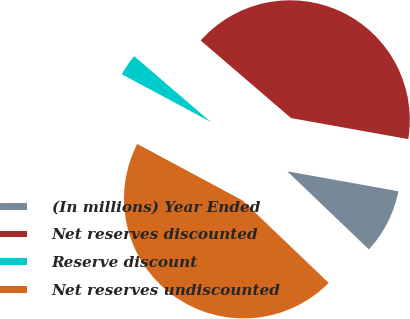Convert chart to OTSL. <chart><loc_0><loc_0><loc_500><loc_500><pie_chart><fcel>(In millions) Year Ended<fcel>Net reserves discounted<fcel>Reserve discount<fcel>Net reserves undiscounted<nl><fcel>9.32%<fcel>41.53%<fcel>3.45%<fcel>45.69%<nl></chart> 